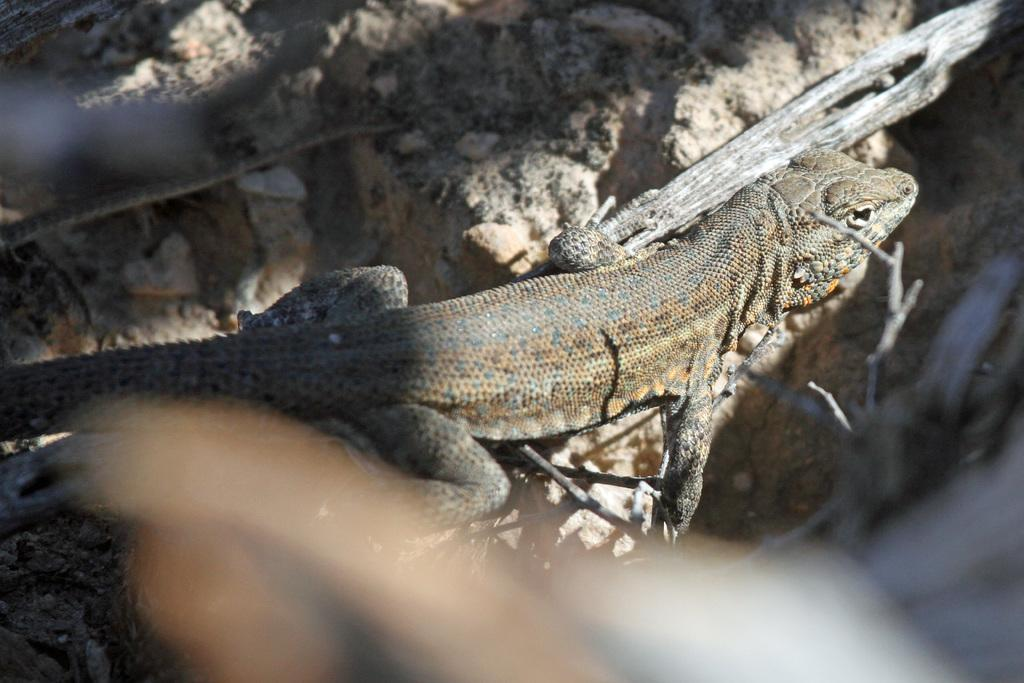What type of animal is in the picture? There is a reptile in the picture. What color is the reptile? The reptile is brown in color. What can be seen in the background of the picture? There is a rock in the background of the picture. What type of behavior is the reptile exhibiting in the picture? The provided facts do not mention any specific behavior of the reptile in the picture. What kind of paint is used on the rock in the background? There is no information about paint on the rock in the background, as it is a natural rock formation. 